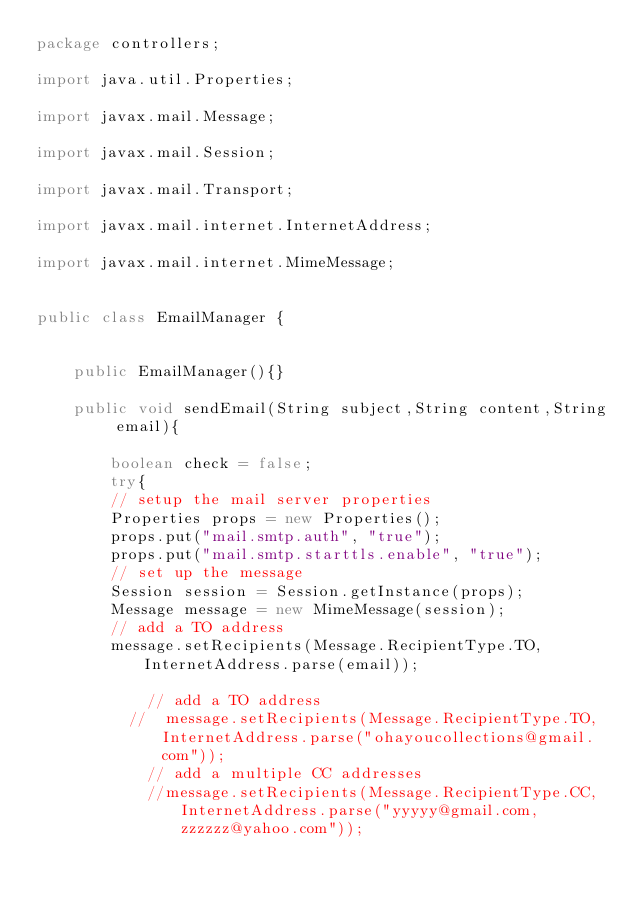<code> <loc_0><loc_0><loc_500><loc_500><_Java_>package controllers;

import java.util.Properties;

import javax.mail.Message;

import javax.mail.Session;

import javax.mail.Transport;

import javax.mail.internet.InternetAddress;

import javax.mail.internet.MimeMessage;


public class EmailManager {


    public EmailManager(){}

    public void sendEmail(String subject,String content,String email){
        
        boolean check = false;
        try{
        // setup the mail server properties
        Properties props = new Properties();
        props.put("mail.smtp.auth", "true");
        props.put("mail.smtp.starttls.enable", "true");
        // set up the message
        Session session = Session.getInstance(props);
        Message message = new MimeMessage(session);
        // add a TO address
        message.setRecipients(Message.RecipientType.TO, InternetAddress.parse(email));
            
            // add a TO address
          //  message.setRecipients(Message.RecipientType.TO, InternetAddress.parse("ohayoucollections@gmail.com"));
            // add a multiple CC addresses
            //message.setRecipients(Message.RecipientType.CC, InternetAddress.parse("yyyyy@gmail.com,zzzzzz@yahoo.com"));</code> 